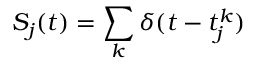Convert formula to latex. <formula><loc_0><loc_0><loc_500><loc_500>S _ { j } ( t ) = \sum _ { k } \delta ( t - t _ { j } ^ { k } )</formula> 